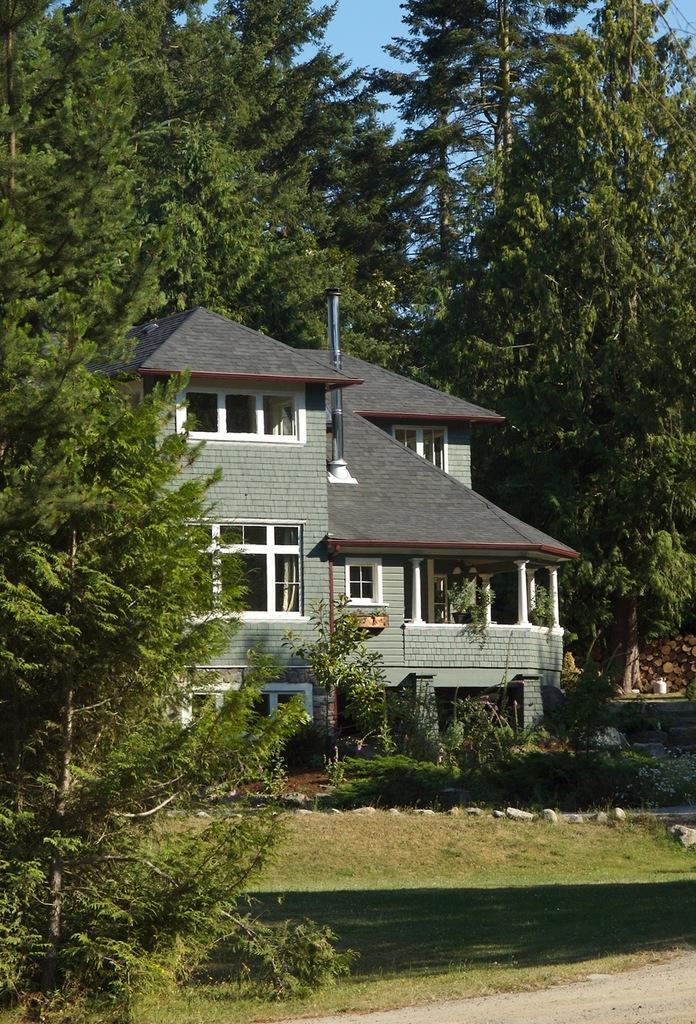How would you summarize this image in a sentence or two? In this image I can see a house, trees, the grass and plants. In the background I can see the sky. 